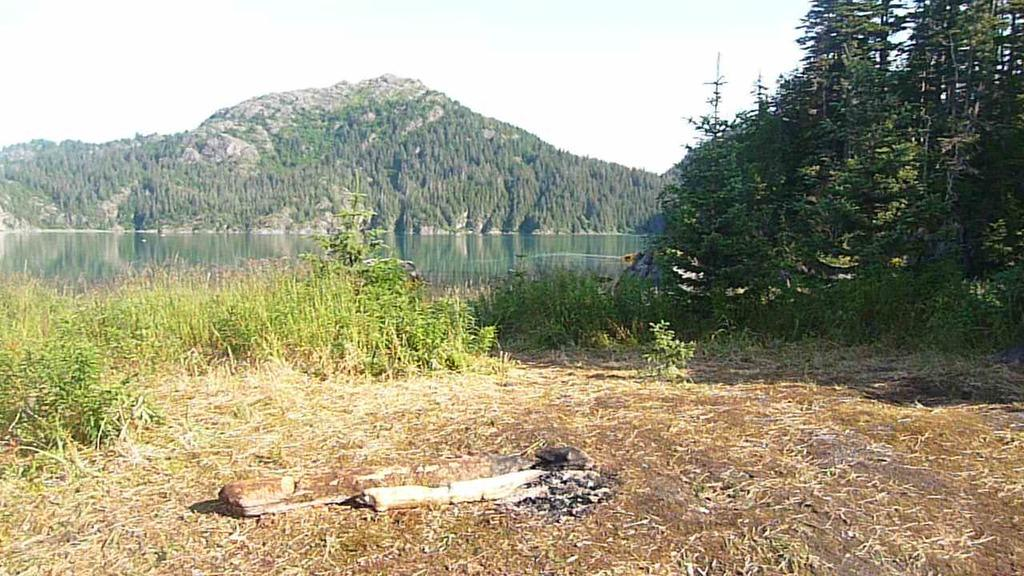What type of vegetation can be seen in the image? There is grass in the image. What natural element is present alongside the grass? There is water in the image. What other natural features can be seen in the image? There are trees and hills in the image. What is visible in the background of the image? The sky is visible in the image. What might be used as fuel or for warmth in the image? There is a half-burned wooden log in the image. How many girls are playing with the yak on the seashore in the image? There are no girls or yaks present in the image, and the image does not depict a seashore. 